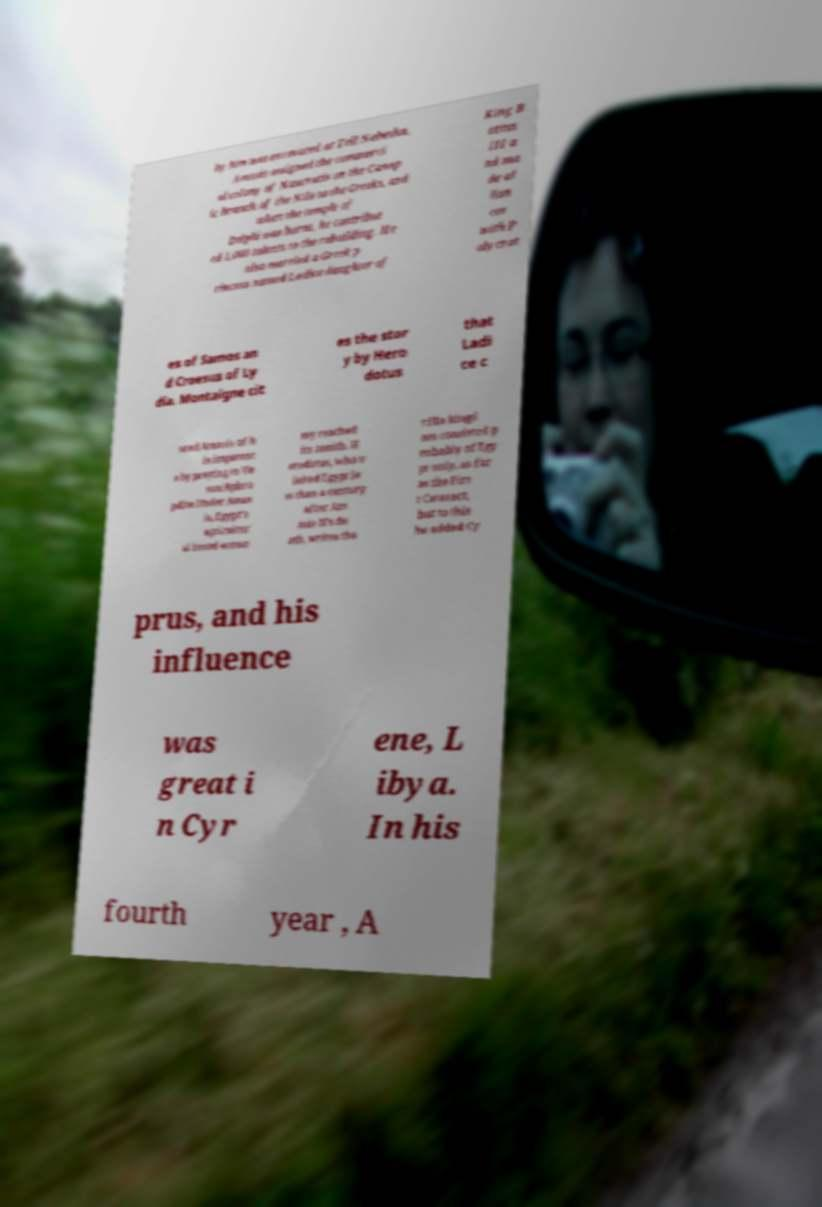I need the written content from this picture converted into text. Can you do that? by him was excavated at Tell Nebesha. Amasis assigned the commerci al colony of Naucratis on the Canop ic branch of the Nile to the Greeks, and when the temple of Delphi was burnt, he contribut ed 1,000 talents to the rebuilding. He also married a Greek p rincess named Ladice daughter of King B attus III a nd ma de al lian ces with P olycrat es of Samos an d Croesus of Ly dia. Montaigne cit es the stor y by Hero dotus that Ladi ce c ured Amasis of h is impotenc e by praying to Ve nus/Aphro pdite.Under Amas is, Egypt's agricultur al based econo my reached its zenith. H erodotus, who v isited Egypt le ss than a century after Am asis II's de ath, writes tha t:His kingd om consisted p robably of Egy pt only, as far as the Firs t Cataract, but to this he added Cy prus, and his influence was great i n Cyr ene, L ibya. In his fourth year , A 